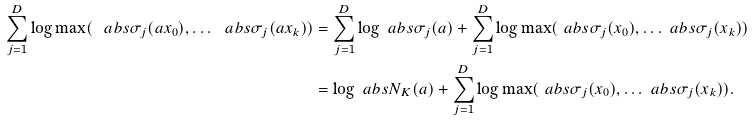<formula> <loc_0><loc_0><loc_500><loc_500>\sum _ { j = 1 } ^ { D } \log \max ( \ a b s { \sigma _ { j } ( a x _ { 0 } ) } , \dots \ a b s { \sigma _ { j } ( a x _ { k } ) } ) & = \sum _ { j = 1 } ^ { D } \log \ a b s { \sigma _ { j } ( a ) } + \sum _ { j = 1 } ^ { D } \log \max ( \ a b s { \sigma _ { j } ( x _ { 0 } ) } , \dots \ a b s { \sigma _ { j } ( x _ { k } ) } ) \\ & = \log \ a b s { N _ { K } ( a ) } + \sum _ { j = 1 } ^ { D } \log \max ( \ a b s { \sigma _ { j } ( x _ { 0 } ) } , \dots \ a b s { \sigma _ { j } ( x _ { k } ) } ) .</formula> 